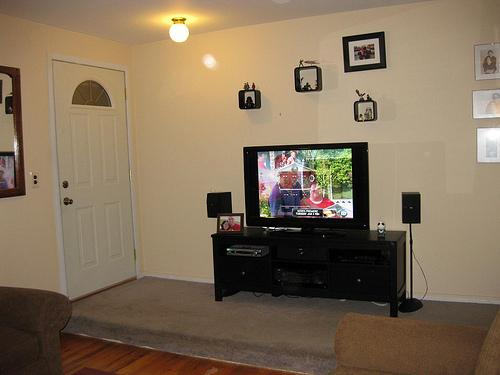Describe the object that is next to the TV and has a width of 243. The object next to the TV with a width of 243 is a black speaker. Identify the primary electronics present in the image. There is a flat screen TV and black speakers beside it in the image. What color is the chair in front of the television? The chair in front of the television is brown. How many doors are visible in the image and what colors are they? There is one visible door in the image, and it is white. How many light sources are present in the image? There is one light source present in the image – a light on the ceiling. Provide a brief description of the scene in the image. The image features a living room scene with a flat screen TV on a black stand, black speakers beside the TV, a picture frame on the wall, a brown chair, a white door, and a light on the ceiling. List the objects present in the image that have a height of 137 or more. TV with black frame, black stand under TV, black speakers, and a flat TV that is on. Count the number of picture frames in the image and describe their locations. There are three picture frames – one on the wall, one on the stand, and one next to the TV. How would you describe the overall sentiment of the image space? The overall sentiment of the image space is cozy, comfortable, and inviting. Are there any numbers visible in the image? No Is there a blue picture frame on the wall? There are picture frames on the wall, but they are described as black or white, not blue. Is there a large window in the white door? There is a small window in the white door, but it is not described as large. Describe the relationship between the objects in the room. The objects work together to create a living room setting with a TV, stand, chair, and decoration. Is the green chair in front of the TV? There is a chair in front of the TV, but it is described as brown, not green. Does the TV have a silver frame? The TV is described as having a black frame, not a silver one. Choose the correct description of the TV. (a) Old and bulky (b) Small and red (c) Flat screen and black Flat screen and black What game is being played on the TV? There is no game being played. The TV is just displaying something. Is there a chair in the image and if so, what color is it? Yes, dark brown Explain the setting in the image as a scene from a story. In the cozy living room, the off-white wall provided the backdrop for a comfortable scene. The flat screen TV held the focus, while a dark brown chair invited reprieve, and the black stand and speakers offered companionship. A delicate touch adorned the scene with a picture on the wall. Be a narrator and describe the placement of the black speakers. Our eyes now drift towards the black speakers, nestled by the TV, a sonic companion to the visual centerpiece of the room. What type of flooring is in the room? Hardwood Does the image depict a calm or chaotic environment? Calm What color is the wall in the image? Off white Craft a short poem inspired by the scene in the image. By the wall off white, What are the words on the ceiling light box? There are no words on the ceiling light box. Identify the event occurring in the living room. There is no specific event happening in the room. Can you see a red door next to the TV? The door next to the TV is described as white, not red. Are there four black shelves on the wall? There are three black shelves on the wall, not four. What activity is the person in front of the TV doing? There is no person in the image. In a casual tone, describe the position of the picture frame. There's a picture frame just chilling on the wall, next to the TV, you know? Detect the presence of a celebration in the room. There is no celebration detected in the room. What is the primary function of the black stand under the TV? To support and display the TV. In a formal tone, provide a brief description of the TV stand. The TV stand appears to be a black, lengthy table, designed to provide support and display for the television. 